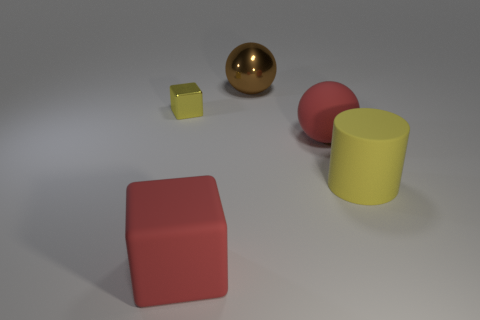There is a yellow rubber cylinder; is it the same size as the metal thing that is left of the big red rubber cube?
Offer a terse response. No. What is the color of the large matte thing that is the same shape as the small metallic object?
Make the answer very short. Red. There is a yellow thing that is on the right side of the small yellow shiny thing; is it the same size as the red rubber thing that is behind the big red cube?
Your response must be concise. Yes. Is the small yellow metal object the same shape as the large shiny thing?
Make the answer very short. No. What number of things are either rubber things that are to the right of the big shiny thing or large red rubber objects?
Give a very brief answer. 3. Are there any tiny things of the same shape as the big shiny object?
Offer a very short reply. No. Is the number of small shiny blocks that are behind the brown object the same as the number of brown shiny spheres?
Your answer should be compact. No. The large matte object that is the same color as the large matte ball is what shape?
Offer a terse response. Cube. What number of red rubber things have the same size as the brown object?
Offer a terse response. 2. There is a matte cube; what number of large red matte cubes are on the left side of it?
Your answer should be very brief. 0. 